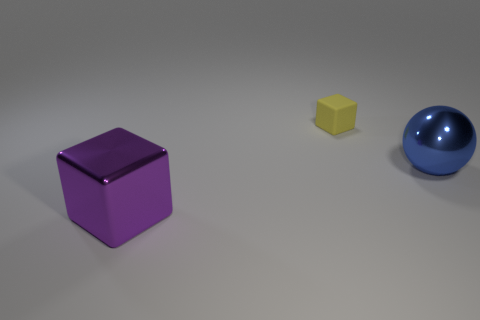Are there any tiny yellow matte cylinders?
Offer a very short reply. No. Are there more metallic things that are on the right side of the large purple shiny thing than large spheres on the left side of the big sphere?
Offer a terse response. Yes. There is a purple cube that is made of the same material as the blue sphere; what is its size?
Make the answer very short. Large. There is a metal object that is left of the large blue metallic sphere that is behind the shiny thing in front of the blue metal ball; how big is it?
Your answer should be compact. Large. What color is the big metallic thing that is right of the yellow cube?
Make the answer very short. Blue. Is the number of big metallic objects on the right side of the purple object greater than the number of big rubber balls?
Your answer should be very brief. Yes. Do the thing that is on the right side of the tiny block and the tiny thing have the same shape?
Your answer should be very brief. No. What number of cyan things are either blocks or large metallic cubes?
Give a very brief answer. 0. Are there more small yellow objects than green objects?
Offer a very short reply. Yes. There is a shiny object that is the same size as the metallic ball; what color is it?
Your response must be concise. Purple. 